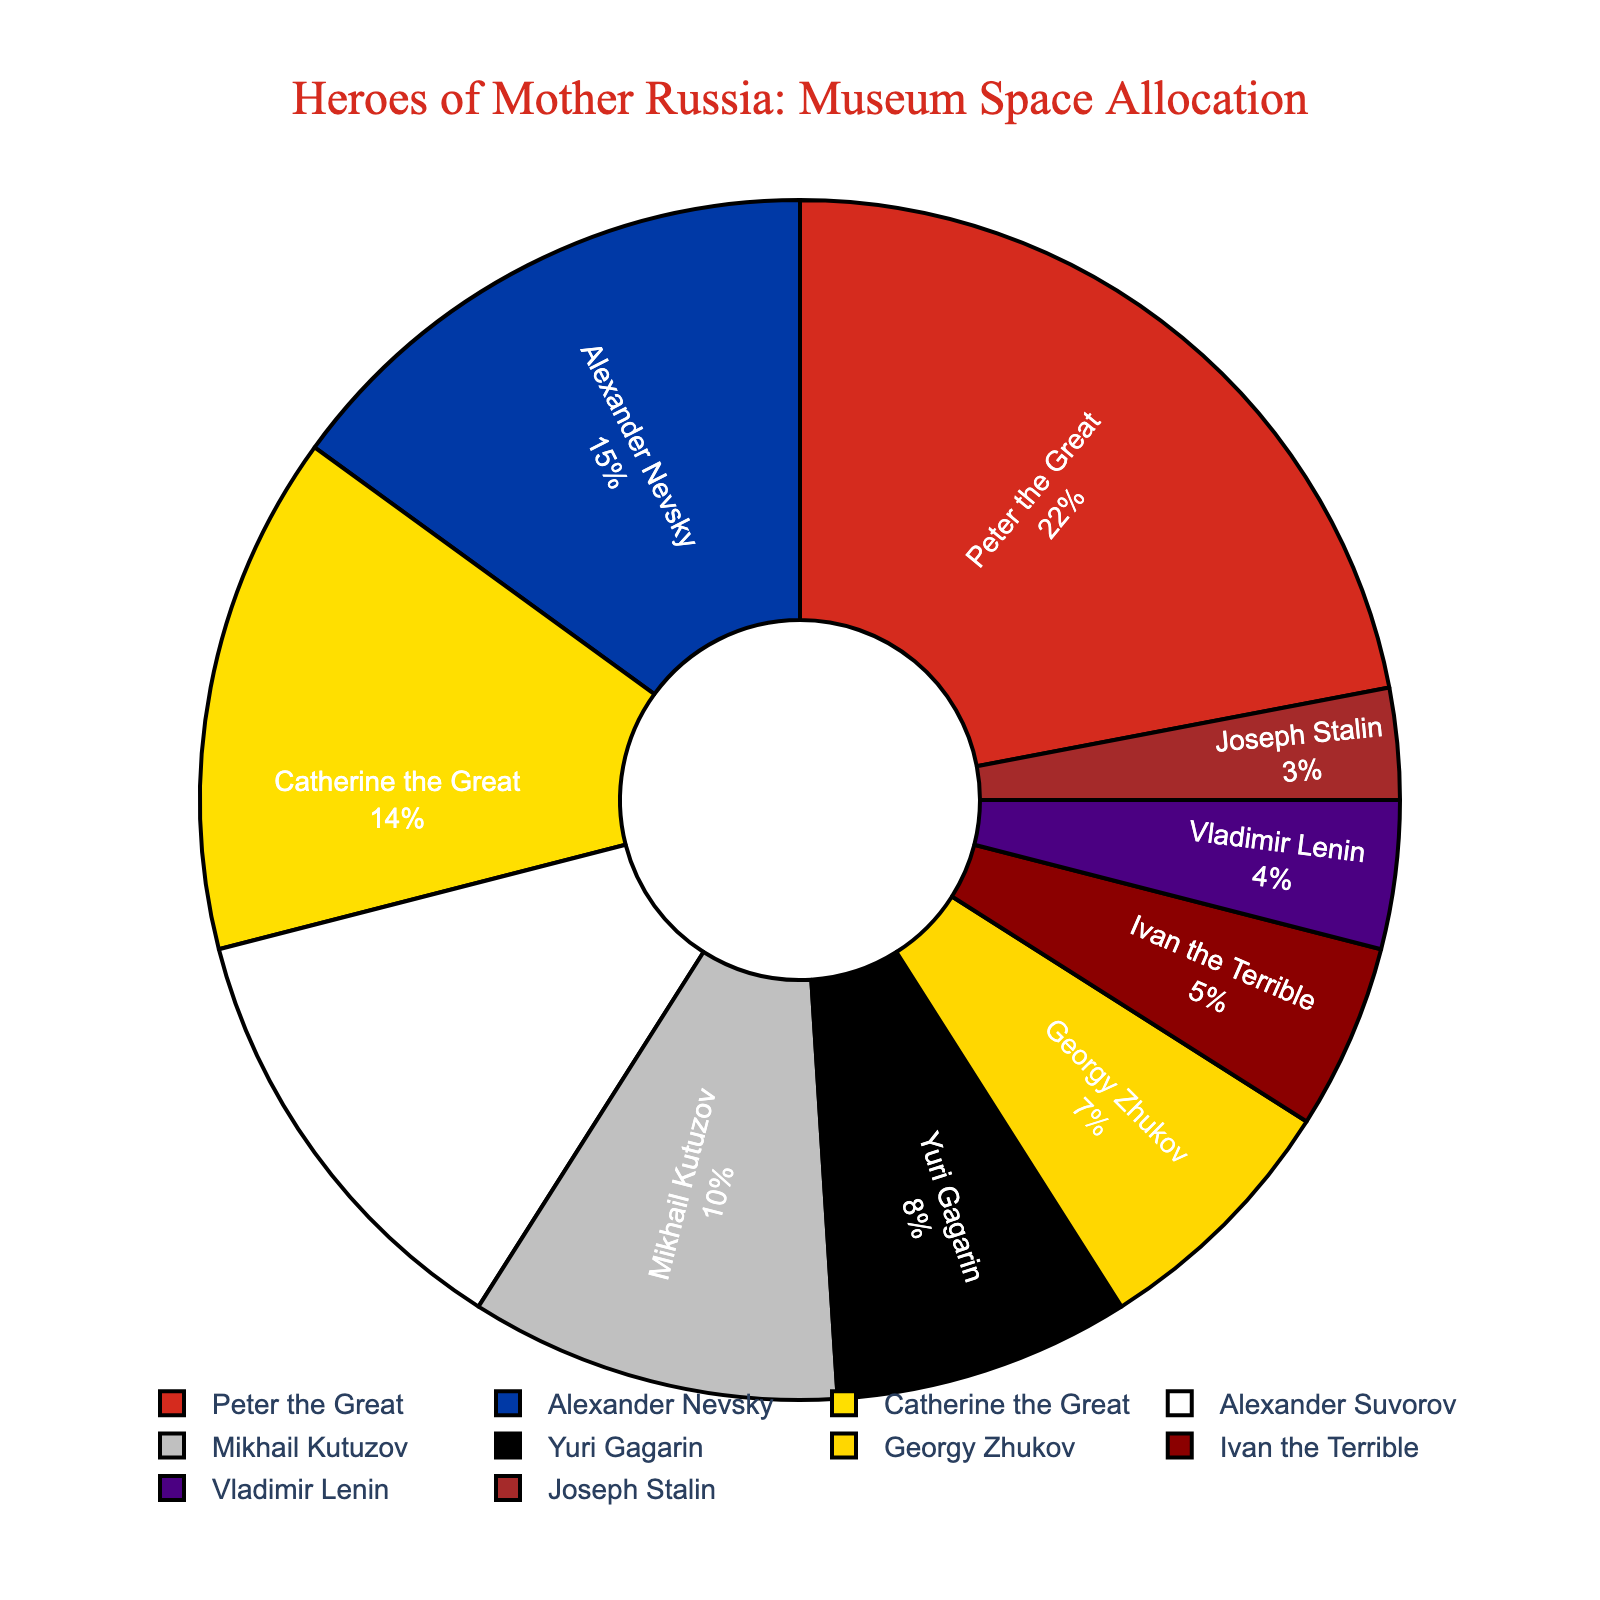Which hero has the largest allocation of museum space? Peter the Great occupies the largest portion of the pie chart. This is evident from the largest pie slice labeled with his name.
Answer: Peter the Great How much more space is dedicated to Peter the Great compared to Joseph Stalin? Peter the Great has 22% of the allocation, while Joseph Stalin has 3%. The difference is 22% - 3% = 19%.
Answer: 19% Which heroes together occupy exactly half of the museum space? Peter the Great (22%) + Alexander Nevsky (15%) + Catherine the Great (14%) total up to 51%, which is closest to half.
Answer: Peter the Great, Alexander Nevsky, Catherine the Great How does the space allocated to military heroes Alexander Suvorov and Mikhail Kutuzov compare? Alexander Suvorov has 12%, and Mikhail Kutuzov has 10%. Comparing them, Alexander Suvorov has 2% more space.
Answer: Alexander Suvorov has 2% more Which hero has less space allocated than Yuri Gagarin but more than Joseph Stalin? Yuri Gagarin has 8%, and Joseph Stalin has 3%. The hero falling between these two allocations is Georgy Zhukov with 7%.
Answer: Georgy Zhukov Are there more space allocated to Ivan the Terrible or Catherine the Great? Catherine the Great has 14%, while Ivan the Terrible has 5%. Therefore, Catherine the Great has more space allocated.
Answer: Catherine the Great Which hero is represented with the red color in the pie chart? By examining the visual color associated with the names, the red portion corresponds to Peter the Great.
Answer: Peter the Great What is the combined space allocation for Vladimir Lenin and Joseph Stalin? Vladimir Lenin has 4% and Joseph Stalin has 3%, summing these gives 4% + 3% = 7%.
Answer: 7% Between Vladimir Lenin and Yuri Gagarin, who has a smaller allocation and by how much? Vladimir Lenin has 4% and Yuri Gagarin has 8%. The difference is 8% - 4% = 4%.
Answer: Vladimir Lenin by 4% 